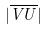<formula> <loc_0><loc_0><loc_500><loc_500>| \overline { V U } |</formula> 